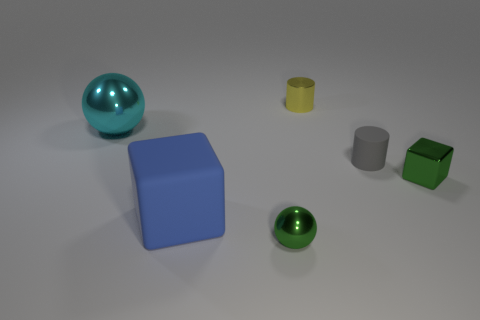Is the large cyan ball made of the same material as the yellow object?
Provide a succinct answer. Yes. The tiny thing that is the same color as the tiny metallic ball is what shape?
Your response must be concise. Cube. There is a tiny cylinder behind the large cyan sphere; is its color the same as the metallic block?
Provide a succinct answer. No. What number of small shiny blocks are behind the shiny ball behind the gray thing?
Your answer should be very brief. 0. What color is the metallic ball that is the same size as the gray rubber object?
Offer a terse response. Green. What is the material of the ball that is behind the green sphere?
Give a very brief answer. Metal. What is the material of the thing that is in front of the big cyan thing and to the left of the small green shiny sphere?
Your answer should be compact. Rubber. There is a ball right of the blue cube; is it the same size as the small matte object?
Your answer should be very brief. Yes. What is the shape of the big cyan metal object?
Your response must be concise. Sphere. How many small gray objects are the same shape as the tiny yellow thing?
Keep it short and to the point. 1. 